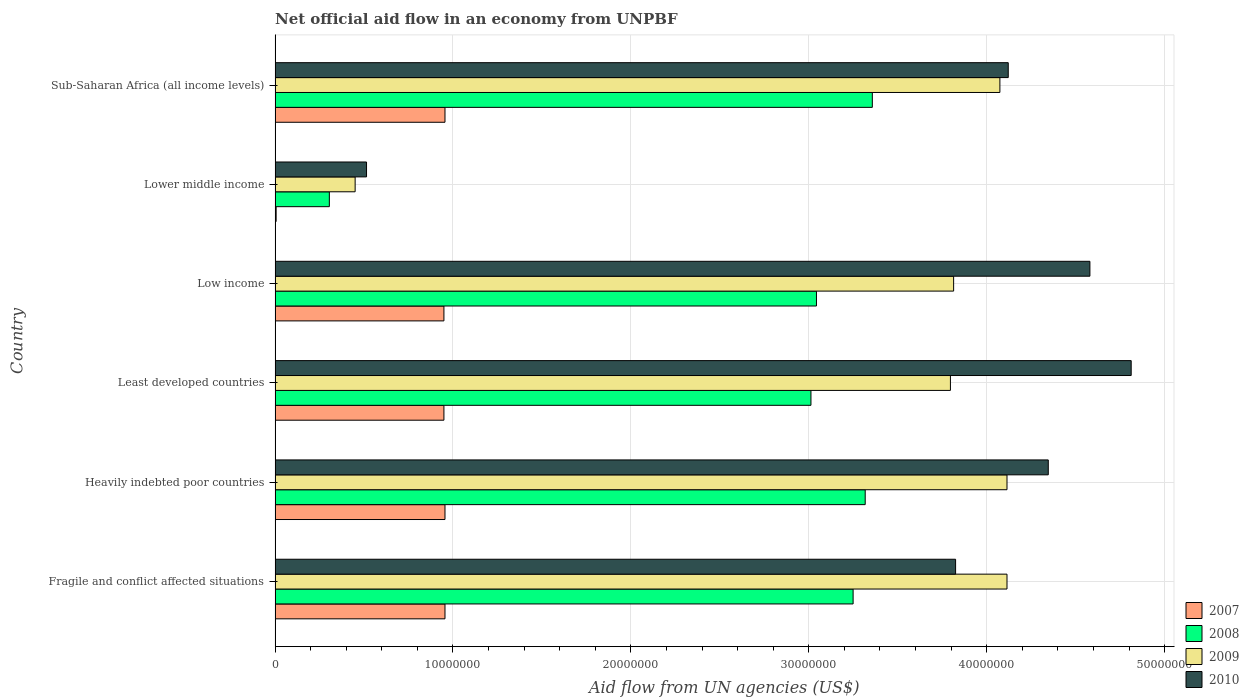How many groups of bars are there?
Give a very brief answer. 6. Are the number of bars per tick equal to the number of legend labels?
Your response must be concise. Yes. Are the number of bars on each tick of the Y-axis equal?
Provide a short and direct response. Yes. What is the label of the 4th group of bars from the top?
Provide a short and direct response. Least developed countries. What is the net official aid flow in 2008 in Fragile and conflict affected situations?
Provide a succinct answer. 3.25e+07. Across all countries, what is the maximum net official aid flow in 2007?
Your response must be concise. 9.55e+06. Across all countries, what is the minimum net official aid flow in 2008?
Give a very brief answer. 3.05e+06. In which country was the net official aid flow in 2007 maximum?
Offer a very short reply. Fragile and conflict affected situations. In which country was the net official aid flow in 2008 minimum?
Offer a terse response. Lower middle income. What is the total net official aid flow in 2007 in the graph?
Provide a succinct answer. 4.77e+07. What is the difference between the net official aid flow in 2010 in Least developed countries and that in Sub-Saharan Africa (all income levels)?
Provide a succinct answer. 6.91e+06. What is the difference between the net official aid flow in 2008 in Heavily indebted poor countries and the net official aid flow in 2009 in Least developed countries?
Provide a short and direct response. -4.79e+06. What is the average net official aid flow in 2007 per country?
Keep it short and to the point. 7.95e+06. What is the difference between the net official aid flow in 2009 and net official aid flow in 2008 in Heavily indebted poor countries?
Your answer should be very brief. 7.97e+06. What is the ratio of the net official aid flow in 2008 in Least developed countries to that in Low income?
Give a very brief answer. 0.99. Is the difference between the net official aid flow in 2009 in Fragile and conflict affected situations and Heavily indebted poor countries greater than the difference between the net official aid flow in 2008 in Fragile and conflict affected situations and Heavily indebted poor countries?
Give a very brief answer. Yes. What is the difference between the highest and the second highest net official aid flow in 2007?
Provide a succinct answer. 0. What is the difference between the highest and the lowest net official aid flow in 2009?
Give a very brief answer. 3.66e+07. In how many countries, is the net official aid flow in 2009 greater than the average net official aid flow in 2009 taken over all countries?
Provide a short and direct response. 5. Is the sum of the net official aid flow in 2010 in Fragile and conflict affected situations and Sub-Saharan Africa (all income levels) greater than the maximum net official aid flow in 2009 across all countries?
Your response must be concise. Yes. What does the 1st bar from the top in Least developed countries represents?
Offer a terse response. 2010. Is it the case that in every country, the sum of the net official aid flow in 2010 and net official aid flow in 2008 is greater than the net official aid flow in 2007?
Keep it short and to the point. Yes. Are all the bars in the graph horizontal?
Provide a succinct answer. Yes. How many countries are there in the graph?
Offer a very short reply. 6. Are the values on the major ticks of X-axis written in scientific E-notation?
Offer a very short reply. No. Where does the legend appear in the graph?
Offer a terse response. Bottom right. What is the title of the graph?
Make the answer very short. Net official aid flow in an economy from UNPBF. Does "1966" appear as one of the legend labels in the graph?
Provide a short and direct response. No. What is the label or title of the X-axis?
Your response must be concise. Aid flow from UN agencies (US$). What is the Aid flow from UN agencies (US$) of 2007 in Fragile and conflict affected situations?
Offer a very short reply. 9.55e+06. What is the Aid flow from UN agencies (US$) in 2008 in Fragile and conflict affected situations?
Offer a very short reply. 3.25e+07. What is the Aid flow from UN agencies (US$) in 2009 in Fragile and conflict affected situations?
Offer a very short reply. 4.11e+07. What is the Aid flow from UN agencies (US$) of 2010 in Fragile and conflict affected situations?
Your answer should be very brief. 3.82e+07. What is the Aid flow from UN agencies (US$) in 2007 in Heavily indebted poor countries?
Offer a terse response. 9.55e+06. What is the Aid flow from UN agencies (US$) of 2008 in Heavily indebted poor countries?
Your response must be concise. 3.32e+07. What is the Aid flow from UN agencies (US$) in 2009 in Heavily indebted poor countries?
Offer a terse response. 4.11e+07. What is the Aid flow from UN agencies (US$) of 2010 in Heavily indebted poor countries?
Offer a terse response. 4.35e+07. What is the Aid flow from UN agencies (US$) of 2007 in Least developed countries?
Offer a terse response. 9.49e+06. What is the Aid flow from UN agencies (US$) in 2008 in Least developed countries?
Offer a very short reply. 3.01e+07. What is the Aid flow from UN agencies (US$) of 2009 in Least developed countries?
Give a very brief answer. 3.80e+07. What is the Aid flow from UN agencies (US$) in 2010 in Least developed countries?
Your answer should be very brief. 4.81e+07. What is the Aid flow from UN agencies (US$) of 2007 in Low income?
Your response must be concise. 9.49e+06. What is the Aid flow from UN agencies (US$) in 2008 in Low income?
Give a very brief answer. 3.04e+07. What is the Aid flow from UN agencies (US$) in 2009 in Low income?
Provide a short and direct response. 3.81e+07. What is the Aid flow from UN agencies (US$) in 2010 in Low income?
Make the answer very short. 4.58e+07. What is the Aid flow from UN agencies (US$) of 2008 in Lower middle income?
Your answer should be very brief. 3.05e+06. What is the Aid flow from UN agencies (US$) of 2009 in Lower middle income?
Your response must be concise. 4.50e+06. What is the Aid flow from UN agencies (US$) in 2010 in Lower middle income?
Your answer should be very brief. 5.14e+06. What is the Aid flow from UN agencies (US$) in 2007 in Sub-Saharan Africa (all income levels)?
Provide a succinct answer. 9.55e+06. What is the Aid flow from UN agencies (US$) in 2008 in Sub-Saharan Africa (all income levels)?
Give a very brief answer. 3.36e+07. What is the Aid flow from UN agencies (US$) of 2009 in Sub-Saharan Africa (all income levels)?
Make the answer very short. 4.07e+07. What is the Aid flow from UN agencies (US$) of 2010 in Sub-Saharan Africa (all income levels)?
Ensure brevity in your answer.  4.12e+07. Across all countries, what is the maximum Aid flow from UN agencies (US$) of 2007?
Make the answer very short. 9.55e+06. Across all countries, what is the maximum Aid flow from UN agencies (US$) in 2008?
Your response must be concise. 3.36e+07. Across all countries, what is the maximum Aid flow from UN agencies (US$) in 2009?
Make the answer very short. 4.11e+07. Across all countries, what is the maximum Aid flow from UN agencies (US$) of 2010?
Your answer should be very brief. 4.81e+07. Across all countries, what is the minimum Aid flow from UN agencies (US$) in 2008?
Your answer should be very brief. 3.05e+06. Across all countries, what is the minimum Aid flow from UN agencies (US$) in 2009?
Provide a succinct answer. 4.50e+06. Across all countries, what is the minimum Aid flow from UN agencies (US$) in 2010?
Provide a succinct answer. 5.14e+06. What is the total Aid flow from UN agencies (US$) in 2007 in the graph?
Make the answer very short. 4.77e+07. What is the total Aid flow from UN agencies (US$) in 2008 in the graph?
Your answer should be very brief. 1.63e+08. What is the total Aid flow from UN agencies (US$) in 2009 in the graph?
Your answer should be compact. 2.04e+08. What is the total Aid flow from UN agencies (US$) in 2010 in the graph?
Provide a short and direct response. 2.22e+08. What is the difference between the Aid flow from UN agencies (US$) of 2007 in Fragile and conflict affected situations and that in Heavily indebted poor countries?
Ensure brevity in your answer.  0. What is the difference between the Aid flow from UN agencies (US$) in 2008 in Fragile and conflict affected situations and that in Heavily indebted poor countries?
Your response must be concise. -6.80e+05. What is the difference between the Aid flow from UN agencies (US$) of 2010 in Fragile and conflict affected situations and that in Heavily indebted poor countries?
Give a very brief answer. -5.21e+06. What is the difference between the Aid flow from UN agencies (US$) of 2007 in Fragile and conflict affected situations and that in Least developed countries?
Provide a succinct answer. 6.00e+04. What is the difference between the Aid flow from UN agencies (US$) of 2008 in Fragile and conflict affected situations and that in Least developed countries?
Your answer should be very brief. 2.37e+06. What is the difference between the Aid flow from UN agencies (US$) of 2009 in Fragile and conflict affected situations and that in Least developed countries?
Provide a short and direct response. 3.18e+06. What is the difference between the Aid flow from UN agencies (US$) of 2010 in Fragile and conflict affected situations and that in Least developed countries?
Ensure brevity in your answer.  -9.87e+06. What is the difference between the Aid flow from UN agencies (US$) in 2007 in Fragile and conflict affected situations and that in Low income?
Make the answer very short. 6.00e+04. What is the difference between the Aid flow from UN agencies (US$) in 2008 in Fragile and conflict affected situations and that in Low income?
Offer a terse response. 2.06e+06. What is the difference between the Aid flow from UN agencies (US$) of 2009 in Fragile and conflict affected situations and that in Low income?
Your answer should be very brief. 3.00e+06. What is the difference between the Aid flow from UN agencies (US$) in 2010 in Fragile and conflict affected situations and that in Low income?
Offer a terse response. -7.55e+06. What is the difference between the Aid flow from UN agencies (US$) of 2007 in Fragile and conflict affected situations and that in Lower middle income?
Offer a terse response. 9.49e+06. What is the difference between the Aid flow from UN agencies (US$) of 2008 in Fragile and conflict affected situations and that in Lower middle income?
Your answer should be very brief. 2.94e+07. What is the difference between the Aid flow from UN agencies (US$) in 2009 in Fragile and conflict affected situations and that in Lower middle income?
Make the answer very short. 3.66e+07. What is the difference between the Aid flow from UN agencies (US$) of 2010 in Fragile and conflict affected situations and that in Lower middle income?
Provide a short and direct response. 3.31e+07. What is the difference between the Aid flow from UN agencies (US$) in 2008 in Fragile and conflict affected situations and that in Sub-Saharan Africa (all income levels)?
Ensure brevity in your answer.  -1.08e+06. What is the difference between the Aid flow from UN agencies (US$) in 2010 in Fragile and conflict affected situations and that in Sub-Saharan Africa (all income levels)?
Your answer should be very brief. -2.96e+06. What is the difference between the Aid flow from UN agencies (US$) of 2007 in Heavily indebted poor countries and that in Least developed countries?
Offer a very short reply. 6.00e+04. What is the difference between the Aid flow from UN agencies (US$) in 2008 in Heavily indebted poor countries and that in Least developed countries?
Your answer should be compact. 3.05e+06. What is the difference between the Aid flow from UN agencies (US$) in 2009 in Heavily indebted poor countries and that in Least developed countries?
Your answer should be very brief. 3.18e+06. What is the difference between the Aid flow from UN agencies (US$) of 2010 in Heavily indebted poor countries and that in Least developed countries?
Make the answer very short. -4.66e+06. What is the difference between the Aid flow from UN agencies (US$) in 2008 in Heavily indebted poor countries and that in Low income?
Offer a terse response. 2.74e+06. What is the difference between the Aid flow from UN agencies (US$) in 2009 in Heavily indebted poor countries and that in Low income?
Ensure brevity in your answer.  3.00e+06. What is the difference between the Aid flow from UN agencies (US$) in 2010 in Heavily indebted poor countries and that in Low income?
Offer a very short reply. -2.34e+06. What is the difference between the Aid flow from UN agencies (US$) of 2007 in Heavily indebted poor countries and that in Lower middle income?
Your answer should be compact. 9.49e+06. What is the difference between the Aid flow from UN agencies (US$) in 2008 in Heavily indebted poor countries and that in Lower middle income?
Make the answer very short. 3.01e+07. What is the difference between the Aid flow from UN agencies (US$) in 2009 in Heavily indebted poor countries and that in Lower middle income?
Give a very brief answer. 3.66e+07. What is the difference between the Aid flow from UN agencies (US$) of 2010 in Heavily indebted poor countries and that in Lower middle income?
Your answer should be compact. 3.83e+07. What is the difference between the Aid flow from UN agencies (US$) in 2008 in Heavily indebted poor countries and that in Sub-Saharan Africa (all income levels)?
Make the answer very short. -4.00e+05. What is the difference between the Aid flow from UN agencies (US$) of 2009 in Heavily indebted poor countries and that in Sub-Saharan Africa (all income levels)?
Your answer should be very brief. 4.00e+05. What is the difference between the Aid flow from UN agencies (US$) in 2010 in Heavily indebted poor countries and that in Sub-Saharan Africa (all income levels)?
Your answer should be compact. 2.25e+06. What is the difference between the Aid flow from UN agencies (US$) of 2007 in Least developed countries and that in Low income?
Make the answer very short. 0. What is the difference between the Aid flow from UN agencies (US$) in 2008 in Least developed countries and that in Low income?
Your response must be concise. -3.10e+05. What is the difference between the Aid flow from UN agencies (US$) in 2009 in Least developed countries and that in Low income?
Provide a succinct answer. -1.80e+05. What is the difference between the Aid flow from UN agencies (US$) of 2010 in Least developed countries and that in Low income?
Your response must be concise. 2.32e+06. What is the difference between the Aid flow from UN agencies (US$) of 2007 in Least developed countries and that in Lower middle income?
Keep it short and to the point. 9.43e+06. What is the difference between the Aid flow from UN agencies (US$) in 2008 in Least developed countries and that in Lower middle income?
Your answer should be compact. 2.71e+07. What is the difference between the Aid flow from UN agencies (US$) in 2009 in Least developed countries and that in Lower middle income?
Give a very brief answer. 3.35e+07. What is the difference between the Aid flow from UN agencies (US$) in 2010 in Least developed countries and that in Lower middle income?
Your response must be concise. 4.30e+07. What is the difference between the Aid flow from UN agencies (US$) of 2008 in Least developed countries and that in Sub-Saharan Africa (all income levels)?
Provide a short and direct response. -3.45e+06. What is the difference between the Aid flow from UN agencies (US$) of 2009 in Least developed countries and that in Sub-Saharan Africa (all income levels)?
Give a very brief answer. -2.78e+06. What is the difference between the Aid flow from UN agencies (US$) in 2010 in Least developed countries and that in Sub-Saharan Africa (all income levels)?
Your answer should be very brief. 6.91e+06. What is the difference between the Aid flow from UN agencies (US$) in 2007 in Low income and that in Lower middle income?
Your response must be concise. 9.43e+06. What is the difference between the Aid flow from UN agencies (US$) of 2008 in Low income and that in Lower middle income?
Offer a terse response. 2.74e+07. What is the difference between the Aid flow from UN agencies (US$) of 2009 in Low income and that in Lower middle income?
Offer a very short reply. 3.36e+07. What is the difference between the Aid flow from UN agencies (US$) of 2010 in Low income and that in Lower middle income?
Provide a short and direct response. 4.07e+07. What is the difference between the Aid flow from UN agencies (US$) of 2007 in Low income and that in Sub-Saharan Africa (all income levels)?
Give a very brief answer. -6.00e+04. What is the difference between the Aid flow from UN agencies (US$) of 2008 in Low income and that in Sub-Saharan Africa (all income levels)?
Keep it short and to the point. -3.14e+06. What is the difference between the Aid flow from UN agencies (US$) of 2009 in Low income and that in Sub-Saharan Africa (all income levels)?
Your response must be concise. -2.60e+06. What is the difference between the Aid flow from UN agencies (US$) of 2010 in Low income and that in Sub-Saharan Africa (all income levels)?
Your answer should be very brief. 4.59e+06. What is the difference between the Aid flow from UN agencies (US$) of 2007 in Lower middle income and that in Sub-Saharan Africa (all income levels)?
Provide a short and direct response. -9.49e+06. What is the difference between the Aid flow from UN agencies (US$) in 2008 in Lower middle income and that in Sub-Saharan Africa (all income levels)?
Offer a very short reply. -3.05e+07. What is the difference between the Aid flow from UN agencies (US$) of 2009 in Lower middle income and that in Sub-Saharan Africa (all income levels)?
Your response must be concise. -3.62e+07. What is the difference between the Aid flow from UN agencies (US$) of 2010 in Lower middle income and that in Sub-Saharan Africa (all income levels)?
Offer a very short reply. -3.61e+07. What is the difference between the Aid flow from UN agencies (US$) in 2007 in Fragile and conflict affected situations and the Aid flow from UN agencies (US$) in 2008 in Heavily indebted poor countries?
Your response must be concise. -2.36e+07. What is the difference between the Aid flow from UN agencies (US$) of 2007 in Fragile and conflict affected situations and the Aid flow from UN agencies (US$) of 2009 in Heavily indebted poor countries?
Give a very brief answer. -3.16e+07. What is the difference between the Aid flow from UN agencies (US$) in 2007 in Fragile and conflict affected situations and the Aid flow from UN agencies (US$) in 2010 in Heavily indebted poor countries?
Ensure brevity in your answer.  -3.39e+07. What is the difference between the Aid flow from UN agencies (US$) of 2008 in Fragile and conflict affected situations and the Aid flow from UN agencies (US$) of 2009 in Heavily indebted poor countries?
Offer a terse response. -8.65e+06. What is the difference between the Aid flow from UN agencies (US$) of 2008 in Fragile and conflict affected situations and the Aid flow from UN agencies (US$) of 2010 in Heavily indebted poor countries?
Your answer should be very brief. -1.10e+07. What is the difference between the Aid flow from UN agencies (US$) in 2009 in Fragile and conflict affected situations and the Aid flow from UN agencies (US$) in 2010 in Heavily indebted poor countries?
Your response must be concise. -2.32e+06. What is the difference between the Aid flow from UN agencies (US$) in 2007 in Fragile and conflict affected situations and the Aid flow from UN agencies (US$) in 2008 in Least developed countries?
Your answer should be very brief. -2.06e+07. What is the difference between the Aid flow from UN agencies (US$) of 2007 in Fragile and conflict affected situations and the Aid flow from UN agencies (US$) of 2009 in Least developed countries?
Keep it short and to the point. -2.84e+07. What is the difference between the Aid flow from UN agencies (US$) in 2007 in Fragile and conflict affected situations and the Aid flow from UN agencies (US$) in 2010 in Least developed countries?
Your answer should be very brief. -3.86e+07. What is the difference between the Aid flow from UN agencies (US$) of 2008 in Fragile and conflict affected situations and the Aid flow from UN agencies (US$) of 2009 in Least developed countries?
Ensure brevity in your answer.  -5.47e+06. What is the difference between the Aid flow from UN agencies (US$) of 2008 in Fragile and conflict affected situations and the Aid flow from UN agencies (US$) of 2010 in Least developed countries?
Offer a terse response. -1.56e+07. What is the difference between the Aid flow from UN agencies (US$) in 2009 in Fragile and conflict affected situations and the Aid flow from UN agencies (US$) in 2010 in Least developed countries?
Provide a succinct answer. -6.98e+06. What is the difference between the Aid flow from UN agencies (US$) in 2007 in Fragile and conflict affected situations and the Aid flow from UN agencies (US$) in 2008 in Low income?
Keep it short and to the point. -2.09e+07. What is the difference between the Aid flow from UN agencies (US$) of 2007 in Fragile and conflict affected situations and the Aid flow from UN agencies (US$) of 2009 in Low income?
Offer a very short reply. -2.86e+07. What is the difference between the Aid flow from UN agencies (US$) in 2007 in Fragile and conflict affected situations and the Aid flow from UN agencies (US$) in 2010 in Low income?
Your answer should be very brief. -3.62e+07. What is the difference between the Aid flow from UN agencies (US$) in 2008 in Fragile and conflict affected situations and the Aid flow from UN agencies (US$) in 2009 in Low income?
Make the answer very short. -5.65e+06. What is the difference between the Aid flow from UN agencies (US$) of 2008 in Fragile and conflict affected situations and the Aid flow from UN agencies (US$) of 2010 in Low income?
Offer a very short reply. -1.33e+07. What is the difference between the Aid flow from UN agencies (US$) in 2009 in Fragile and conflict affected situations and the Aid flow from UN agencies (US$) in 2010 in Low income?
Keep it short and to the point. -4.66e+06. What is the difference between the Aid flow from UN agencies (US$) in 2007 in Fragile and conflict affected situations and the Aid flow from UN agencies (US$) in 2008 in Lower middle income?
Keep it short and to the point. 6.50e+06. What is the difference between the Aid flow from UN agencies (US$) in 2007 in Fragile and conflict affected situations and the Aid flow from UN agencies (US$) in 2009 in Lower middle income?
Ensure brevity in your answer.  5.05e+06. What is the difference between the Aid flow from UN agencies (US$) of 2007 in Fragile and conflict affected situations and the Aid flow from UN agencies (US$) of 2010 in Lower middle income?
Ensure brevity in your answer.  4.41e+06. What is the difference between the Aid flow from UN agencies (US$) in 2008 in Fragile and conflict affected situations and the Aid flow from UN agencies (US$) in 2009 in Lower middle income?
Provide a succinct answer. 2.80e+07. What is the difference between the Aid flow from UN agencies (US$) in 2008 in Fragile and conflict affected situations and the Aid flow from UN agencies (US$) in 2010 in Lower middle income?
Your response must be concise. 2.74e+07. What is the difference between the Aid flow from UN agencies (US$) in 2009 in Fragile and conflict affected situations and the Aid flow from UN agencies (US$) in 2010 in Lower middle income?
Offer a terse response. 3.60e+07. What is the difference between the Aid flow from UN agencies (US$) in 2007 in Fragile and conflict affected situations and the Aid flow from UN agencies (US$) in 2008 in Sub-Saharan Africa (all income levels)?
Provide a succinct answer. -2.40e+07. What is the difference between the Aid flow from UN agencies (US$) of 2007 in Fragile and conflict affected situations and the Aid flow from UN agencies (US$) of 2009 in Sub-Saharan Africa (all income levels)?
Your answer should be compact. -3.12e+07. What is the difference between the Aid flow from UN agencies (US$) of 2007 in Fragile and conflict affected situations and the Aid flow from UN agencies (US$) of 2010 in Sub-Saharan Africa (all income levels)?
Offer a very short reply. -3.17e+07. What is the difference between the Aid flow from UN agencies (US$) of 2008 in Fragile and conflict affected situations and the Aid flow from UN agencies (US$) of 2009 in Sub-Saharan Africa (all income levels)?
Your response must be concise. -8.25e+06. What is the difference between the Aid flow from UN agencies (US$) of 2008 in Fragile and conflict affected situations and the Aid flow from UN agencies (US$) of 2010 in Sub-Saharan Africa (all income levels)?
Provide a succinct answer. -8.72e+06. What is the difference between the Aid flow from UN agencies (US$) of 2009 in Fragile and conflict affected situations and the Aid flow from UN agencies (US$) of 2010 in Sub-Saharan Africa (all income levels)?
Your answer should be very brief. -7.00e+04. What is the difference between the Aid flow from UN agencies (US$) of 2007 in Heavily indebted poor countries and the Aid flow from UN agencies (US$) of 2008 in Least developed countries?
Your response must be concise. -2.06e+07. What is the difference between the Aid flow from UN agencies (US$) in 2007 in Heavily indebted poor countries and the Aid flow from UN agencies (US$) in 2009 in Least developed countries?
Give a very brief answer. -2.84e+07. What is the difference between the Aid flow from UN agencies (US$) in 2007 in Heavily indebted poor countries and the Aid flow from UN agencies (US$) in 2010 in Least developed countries?
Your answer should be very brief. -3.86e+07. What is the difference between the Aid flow from UN agencies (US$) in 2008 in Heavily indebted poor countries and the Aid flow from UN agencies (US$) in 2009 in Least developed countries?
Your response must be concise. -4.79e+06. What is the difference between the Aid flow from UN agencies (US$) of 2008 in Heavily indebted poor countries and the Aid flow from UN agencies (US$) of 2010 in Least developed countries?
Provide a short and direct response. -1.50e+07. What is the difference between the Aid flow from UN agencies (US$) in 2009 in Heavily indebted poor countries and the Aid flow from UN agencies (US$) in 2010 in Least developed countries?
Offer a very short reply. -6.98e+06. What is the difference between the Aid flow from UN agencies (US$) of 2007 in Heavily indebted poor countries and the Aid flow from UN agencies (US$) of 2008 in Low income?
Your response must be concise. -2.09e+07. What is the difference between the Aid flow from UN agencies (US$) of 2007 in Heavily indebted poor countries and the Aid flow from UN agencies (US$) of 2009 in Low income?
Provide a short and direct response. -2.86e+07. What is the difference between the Aid flow from UN agencies (US$) in 2007 in Heavily indebted poor countries and the Aid flow from UN agencies (US$) in 2010 in Low income?
Offer a terse response. -3.62e+07. What is the difference between the Aid flow from UN agencies (US$) of 2008 in Heavily indebted poor countries and the Aid flow from UN agencies (US$) of 2009 in Low income?
Your response must be concise. -4.97e+06. What is the difference between the Aid flow from UN agencies (US$) of 2008 in Heavily indebted poor countries and the Aid flow from UN agencies (US$) of 2010 in Low income?
Provide a succinct answer. -1.26e+07. What is the difference between the Aid flow from UN agencies (US$) in 2009 in Heavily indebted poor countries and the Aid flow from UN agencies (US$) in 2010 in Low income?
Give a very brief answer. -4.66e+06. What is the difference between the Aid flow from UN agencies (US$) in 2007 in Heavily indebted poor countries and the Aid flow from UN agencies (US$) in 2008 in Lower middle income?
Keep it short and to the point. 6.50e+06. What is the difference between the Aid flow from UN agencies (US$) of 2007 in Heavily indebted poor countries and the Aid flow from UN agencies (US$) of 2009 in Lower middle income?
Provide a succinct answer. 5.05e+06. What is the difference between the Aid flow from UN agencies (US$) of 2007 in Heavily indebted poor countries and the Aid flow from UN agencies (US$) of 2010 in Lower middle income?
Offer a very short reply. 4.41e+06. What is the difference between the Aid flow from UN agencies (US$) in 2008 in Heavily indebted poor countries and the Aid flow from UN agencies (US$) in 2009 in Lower middle income?
Ensure brevity in your answer.  2.87e+07. What is the difference between the Aid flow from UN agencies (US$) in 2008 in Heavily indebted poor countries and the Aid flow from UN agencies (US$) in 2010 in Lower middle income?
Make the answer very short. 2.80e+07. What is the difference between the Aid flow from UN agencies (US$) in 2009 in Heavily indebted poor countries and the Aid flow from UN agencies (US$) in 2010 in Lower middle income?
Provide a succinct answer. 3.60e+07. What is the difference between the Aid flow from UN agencies (US$) in 2007 in Heavily indebted poor countries and the Aid flow from UN agencies (US$) in 2008 in Sub-Saharan Africa (all income levels)?
Keep it short and to the point. -2.40e+07. What is the difference between the Aid flow from UN agencies (US$) in 2007 in Heavily indebted poor countries and the Aid flow from UN agencies (US$) in 2009 in Sub-Saharan Africa (all income levels)?
Give a very brief answer. -3.12e+07. What is the difference between the Aid flow from UN agencies (US$) of 2007 in Heavily indebted poor countries and the Aid flow from UN agencies (US$) of 2010 in Sub-Saharan Africa (all income levels)?
Provide a short and direct response. -3.17e+07. What is the difference between the Aid flow from UN agencies (US$) in 2008 in Heavily indebted poor countries and the Aid flow from UN agencies (US$) in 2009 in Sub-Saharan Africa (all income levels)?
Your answer should be compact. -7.57e+06. What is the difference between the Aid flow from UN agencies (US$) in 2008 in Heavily indebted poor countries and the Aid flow from UN agencies (US$) in 2010 in Sub-Saharan Africa (all income levels)?
Offer a terse response. -8.04e+06. What is the difference between the Aid flow from UN agencies (US$) of 2007 in Least developed countries and the Aid flow from UN agencies (US$) of 2008 in Low income?
Ensure brevity in your answer.  -2.09e+07. What is the difference between the Aid flow from UN agencies (US$) in 2007 in Least developed countries and the Aid flow from UN agencies (US$) in 2009 in Low income?
Provide a short and direct response. -2.86e+07. What is the difference between the Aid flow from UN agencies (US$) in 2007 in Least developed countries and the Aid flow from UN agencies (US$) in 2010 in Low income?
Your response must be concise. -3.63e+07. What is the difference between the Aid flow from UN agencies (US$) in 2008 in Least developed countries and the Aid flow from UN agencies (US$) in 2009 in Low income?
Your answer should be compact. -8.02e+06. What is the difference between the Aid flow from UN agencies (US$) in 2008 in Least developed countries and the Aid flow from UN agencies (US$) in 2010 in Low income?
Your response must be concise. -1.57e+07. What is the difference between the Aid flow from UN agencies (US$) of 2009 in Least developed countries and the Aid flow from UN agencies (US$) of 2010 in Low income?
Your answer should be compact. -7.84e+06. What is the difference between the Aid flow from UN agencies (US$) in 2007 in Least developed countries and the Aid flow from UN agencies (US$) in 2008 in Lower middle income?
Offer a very short reply. 6.44e+06. What is the difference between the Aid flow from UN agencies (US$) of 2007 in Least developed countries and the Aid flow from UN agencies (US$) of 2009 in Lower middle income?
Ensure brevity in your answer.  4.99e+06. What is the difference between the Aid flow from UN agencies (US$) in 2007 in Least developed countries and the Aid flow from UN agencies (US$) in 2010 in Lower middle income?
Keep it short and to the point. 4.35e+06. What is the difference between the Aid flow from UN agencies (US$) of 2008 in Least developed countries and the Aid flow from UN agencies (US$) of 2009 in Lower middle income?
Offer a very short reply. 2.56e+07. What is the difference between the Aid flow from UN agencies (US$) of 2008 in Least developed countries and the Aid flow from UN agencies (US$) of 2010 in Lower middle income?
Provide a short and direct response. 2.50e+07. What is the difference between the Aid flow from UN agencies (US$) of 2009 in Least developed countries and the Aid flow from UN agencies (US$) of 2010 in Lower middle income?
Keep it short and to the point. 3.28e+07. What is the difference between the Aid flow from UN agencies (US$) of 2007 in Least developed countries and the Aid flow from UN agencies (US$) of 2008 in Sub-Saharan Africa (all income levels)?
Keep it short and to the point. -2.41e+07. What is the difference between the Aid flow from UN agencies (US$) in 2007 in Least developed countries and the Aid flow from UN agencies (US$) in 2009 in Sub-Saharan Africa (all income levels)?
Offer a terse response. -3.12e+07. What is the difference between the Aid flow from UN agencies (US$) of 2007 in Least developed countries and the Aid flow from UN agencies (US$) of 2010 in Sub-Saharan Africa (all income levels)?
Provide a succinct answer. -3.17e+07. What is the difference between the Aid flow from UN agencies (US$) of 2008 in Least developed countries and the Aid flow from UN agencies (US$) of 2009 in Sub-Saharan Africa (all income levels)?
Ensure brevity in your answer.  -1.06e+07. What is the difference between the Aid flow from UN agencies (US$) of 2008 in Least developed countries and the Aid flow from UN agencies (US$) of 2010 in Sub-Saharan Africa (all income levels)?
Provide a succinct answer. -1.11e+07. What is the difference between the Aid flow from UN agencies (US$) in 2009 in Least developed countries and the Aid flow from UN agencies (US$) in 2010 in Sub-Saharan Africa (all income levels)?
Provide a succinct answer. -3.25e+06. What is the difference between the Aid flow from UN agencies (US$) of 2007 in Low income and the Aid flow from UN agencies (US$) of 2008 in Lower middle income?
Offer a very short reply. 6.44e+06. What is the difference between the Aid flow from UN agencies (US$) of 2007 in Low income and the Aid flow from UN agencies (US$) of 2009 in Lower middle income?
Offer a terse response. 4.99e+06. What is the difference between the Aid flow from UN agencies (US$) of 2007 in Low income and the Aid flow from UN agencies (US$) of 2010 in Lower middle income?
Make the answer very short. 4.35e+06. What is the difference between the Aid flow from UN agencies (US$) of 2008 in Low income and the Aid flow from UN agencies (US$) of 2009 in Lower middle income?
Keep it short and to the point. 2.59e+07. What is the difference between the Aid flow from UN agencies (US$) in 2008 in Low income and the Aid flow from UN agencies (US$) in 2010 in Lower middle income?
Provide a short and direct response. 2.53e+07. What is the difference between the Aid flow from UN agencies (US$) of 2009 in Low income and the Aid flow from UN agencies (US$) of 2010 in Lower middle income?
Ensure brevity in your answer.  3.30e+07. What is the difference between the Aid flow from UN agencies (US$) in 2007 in Low income and the Aid flow from UN agencies (US$) in 2008 in Sub-Saharan Africa (all income levels)?
Offer a terse response. -2.41e+07. What is the difference between the Aid flow from UN agencies (US$) of 2007 in Low income and the Aid flow from UN agencies (US$) of 2009 in Sub-Saharan Africa (all income levels)?
Ensure brevity in your answer.  -3.12e+07. What is the difference between the Aid flow from UN agencies (US$) of 2007 in Low income and the Aid flow from UN agencies (US$) of 2010 in Sub-Saharan Africa (all income levels)?
Offer a very short reply. -3.17e+07. What is the difference between the Aid flow from UN agencies (US$) in 2008 in Low income and the Aid flow from UN agencies (US$) in 2009 in Sub-Saharan Africa (all income levels)?
Make the answer very short. -1.03e+07. What is the difference between the Aid flow from UN agencies (US$) in 2008 in Low income and the Aid flow from UN agencies (US$) in 2010 in Sub-Saharan Africa (all income levels)?
Ensure brevity in your answer.  -1.08e+07. What is the difference between the Aid flow from UN agencies (US$) of 2009 in Low income and the Aid flow from UN agencies (US$) of 2010 in Sub-Saharan Africa (all income levels)?
Offer a terse response. -3.07e+06. What is the difference between the Aid flow from UN agencies (US$) in 2007 in Lower middle income and the Aid flow from UN agencies (US$) in 2008 in Sub-Saharan Africa (all income levels)?
Your response must be concise. -3.35e+07. What is the difference between the Aid flow from UN agencies (US$) of 2007 in Lower middle income and the Aid flow from UN agencies (US$) of 2009 in Sub-Saharan Africa (all income levels)?
Keep it short and to the point. -4.07e+07. What is the difference between the Aid flow from UN agencies (US$) of 2007 in Lower middle income and the Aid flow from UN agencies (US$) of 2010 in Sub-Saharan Africa (all income levels)?
Provide a short and direct response. -4.12e+07. What is the difference between the Aid flow from UN agencies (US$) of 2008 in Lower middle income and the Aid flow from UN agencies (US$) of 2009 in Sub-Saharan Africa (all income levels)?
Offer a terse response. -3.77e+07. What is the difference between the Aid flow from UN agencies (US$) of 2008 in Lower middle income and the Aid flow from UN agencies (US$) of 2010 in Sub-Saharan Africa (all income levels)?
Your response must be concise. -3.82e+07. What is the difference between the Aid flow from UN agencies (US$) of 2009 in Lower middle income and the Aid flow from UN agencies (US$) of 2010 in Sub-Saharan Africa (all income levels)?
Give a very brief answer. -3.67e+07. What is the average Aid flow from UN agencies (US$) of 2007 per country?
Your answer should be compact. 7.95e+06. What is the average Aid flow from UN agencies (US$) of 2008 per country?
Provide a succinct answer. 2.71e+07. What is the average Aid flow from UN agencies (US$) in 2009 per country?
Provide a short and direct response. 3.39e+07. What is the average Aid flow from UN agencies (US$) of 2010 per country?
Offer a terse response. 3.70e+07. What is the difference between the Aid flow from UN agencies (US$) of 2007 and Aid flow from UN agencies (US$) of 2008 in Fragile and conflict affected situations?
Offer a terse response. -2.29e+07. What is the difference between the Aid flow from UN agencies (US$) in 2007 and Aid flow from UN agencies (US$) in 2009 in Fragile and conflict affected situations?
Provide a succinct answer. -3.16e+07. What is the difference between the Aid flow from UN agencies (US$) in 2007 and Aid flow from UN agencies (US$) in 2010 in Fragile and conflict affected situations?
Make the answer very short. -2.87e+07. What is the difference between the Aid flow from UN agencies (US$) in 2008 and Aid flow from UN agencies (US$) in 2009 in Fragile and conflict affected situations?
Offer a terse response. -8.65e+06. What is the difference between the Aid flow from UN agencies (US$) of 2008 and Aid flow from UN agencies (US$) of 2010 in Fragile and conflict affected situations?
Make the answer very short. -5.76e+06. What is the difference between the Aid flow from UN agencies (US$) in 2009 and Aid flow from UN agencies (US$) in 2010 in Fragile and conflict affected situations?
Make the answer very short. 2.89e+06. What is the difference between the Aid flow from UN agencies (US$) in 2007 and Aid flow from UN agencies (US$) in 2008 in Heavily indebted poor countries?
Your answer should be compact. -2.36e+07. What is the difference between the Aid flow from UN agencies (US$) of 2007 and Aid flow from UN agencies (US$) of 2009 in Heavily indebted poor countries?
Your answer should be compact. -3.16e+07. What is the difference between the Aid flow from UN agencies (US$) in 2007 and Aid flow from UN agencies (US$) in 2010 in Heavily indebted poor countries?
Offer a very short reply. -3.39e+07. What is the difference between the Aid flow from UN agencies (US$) in 2008 and Aid flow from UN agencies (US$) in 2009 in Heavily indebted poor countries?
Provide a succinct answer. -7.97e+06. What is the difference between the Aid flow from UN agencies (US$) in 2008 and Aid flow from UN agencies (US$) in 2010 in Heavily indebted poor countries?
Your answer should be compact. -1.03e+07. What is the difference between the Aid flow from UN agencies (US$) of 2009 and Aid flow from UN agencies (US$) of 2010 in Heavily indebted poor countries?
Keep it short and to the point. -2.32e+06. What is the difference between the Aid flow from UN agencies (US$) of 2007 and Aid flow from UN agencies (US$) of 2008 in Least developed countries?
Your answer should be very brief. -2.06e+07. What is the difference between the Aid flow from UN agencies (US$) of 2007 and Aid flow from UN agencies (US$) of 2009 in Least developed countries?
Your answer should be very brief. -2.85e+07. What is the difference between the Aid flow from UN agencies (US$) in 2007 and Aid flow from UN agencies (US$) in 2010 in Least developed countries?
Your answer should be compact. -3.86e+07. What is the difference between the Aid flow from UN agencies (US$) of 2008 and Aid flow from UN agencies (US$) of 2009 in Least developed countries?
Offer a very short reply. -7.84e+06. What is the difference between the Aid flow from UN agencies (US$) in 2008 and Aid flow from UN agencies (US$) in 2010 in Least developed countries?
Make the answer very short. -1.80e+07. What is the difference between the Aid flow from UN agencies (US$) of 2009 and Aid flow from UN agencies (US$) of 2010 in Least developed countries?
Your answer should be compact. -1.02e+07. What is the difference between the Aid flow from UN agencies (US$) of 2007 and Aid flow from UN agencies (US$) of 2008 in Low income?
Offer a terse response. -2.09e+07. What is the difference between the Aid flow from UN agencies (US$) of 2007 and Aid flow from UN agencies (US$) of 2009 in Low income?
Your answer should be very brief. -2.86e+07. What is the difference between the Aid flow from UN agencies (US$) in 2007 and Aid flow from UN agencies (US$) in 2010 in Low income?
Ensure brevity in your answer.  -3.63e+07. What is the difference between the Aid flow from UN agencies (US$) of 2008 and Aid flow from UN agencies (US$) of 2009 in Low income?
Your answer should be compact. -7.71e+06. What is the difference between the Aid flow from UN agencies (US$) in 2008 and Aid flow from UN agencies (US$) in 2010 in Low income?
Ensure brevity in your answer.  -1.54e+07. What is the difference between the Aid flow from UN agencies (US$) of 2009 and Aid flow from UN agencies (US$) of 2010 in Low income?
Keep it short and to the point. -7.66e+06. What is the difference between the Aid flow from UN agencies (US$) in 2007 and Aid flow from UN agencies (US$) in 2008 in Lower middle income?
Provide a succinct answer. -2.99e+06. What is the difference between the Aid flow from UN agencies (US$) of 2007 and Aid flow from UN agencies (US$) of 2009 in Lower middle income?
Your answer should be very brief. -4.44e+06. What is the difference between the Aid flow from UN agencies (US$) in 2007 and Aid flow from UN agencies (US$) in 2010 in Lower middle income?
Make the answer very short. -5.08e+06. What is the difference between the Aid flow from UN agencies (US$) of 2008 and Aid flow from UN agencies (US$) of 2009 in Lower middle income?
Keep it short and to the point. -1.45e+06. What is the difference between the Aid flow from UN agencies (US$) of 2008 and Aid flow from UN agencies (US$) of 2010 in Lower middle income?
Provide a short and direct response. -2.09e+06. What is the difference between the Aid flow from UN agencies (US$) of 2009 and Aid flow from UN agencies (US$) of 2010 in Lower middle income?
Make the answer very short. -6.40e+05. What is the difference between the Aid flow from UN agencies (US$) of 2007 and Aid flow from UN agencies (US$) of 2008 in Sub-Saharan Africa (all income levels)?
Offer a terse response. -2.40e+07. What is the difference between the Aid flow from UN agencies (US$) of 2007 and Aid flow from UN agencies (US$) of 2009 in Sub-Saharan Africa (all income levels)?
Provide a short and direct response. -3.12e+07. What is the difference between the Aid flow from UN agencies (US$) of 2007 and Aid flow from UN agencies (US$) of 2010 in Sub-Saharan Africa (all income levels)?
Give a very brief answer. -3.17e+07. What is the difference between the Aid flow from UN agencies (US$) in 2008 and Aid flow from UN agencies (US$) in 2009 in Sub-Saharan Africa (all income levels)?
Offer a very short reply. -7.17e+06. What is the difference between the Aid flow from UN agencies (US$) in 2008 and Aid flow from UN agencies (US$) in 2010 in Sub-Saharan Africa (all income levels)?
Give a very brief answer. -7.64e+06. What is the difference between the Aid flow from UN agencies (US$) of 2009 and Aid flow from UN agencies (US$) of 2010 in Sub-Saharan Africa (all income levels)?
Provide a short and direct response. -4.70e+05. What is the ratio of the Aid flow from UN agencies (US$) of 2007 in Fragile and conflict affected situations to that in Heavily indebted poor countries?
Offer a terse response. 1. What is the ratio of the Aid flow from UN agencies (US$) in 2008 in Fragile and conflict affected situations to that in Heavily indebted poor countries?
Give a very brief answer. 0.98. What is the ratio of the Aid flow from UN agencies (US$) in 2009 in Fragile and conflict affected situations to that in Heavily indebted poor countries?
Keep it short and to the point. 1. What is the ratio of the Aid flow from UN agencies (US$) of 2010 in Fragile and conflict affected situations to that in Heavily indebted poor countries?
Offer a very short reply. 0.88. What is the ratio of the Aid flow from UN agencies (US$) in 2007 in Fragile and conflict affected situations to that in Least developed countries?
Offer a very short reply. 1.01. What is the ratio of the Aid flow from UN agencies (US$) of 2008 in Fragile and conflict affected situations to that in Least developed countries?
Provide a succinct answer. 1.08. What is the ratio of the Aid flow from UN agencies (US$) of 2009 in Fragile and conflict affected situations to that in Least developed countries?
Give a very brief answer. 1.08. What is the ratio of the Aid flow from UN agencies (US$) of 2010 in Fragile and conflict affected situations to that in Least developed countries?
Your answer should be very brief. 0.79. What is the ratio of the Aid flow from UN agencies (US$) in 2007 in Fragile and conflict affected situations to that in Low income?
Your answer should be very brief. 1.01. What is the ratio of the Aid flow from UN agencies (US$) of 2008 in Fragile and conflict affected situations to that in Low income?
Provide a short and direct response. 1.07. What is the ratio of the Aid flow from UN agencies (US$) of 2009 in Fragile and conflict affected situations to that in Low income?
Offer a terse response. 1.08. What is the ratio of the Aid flow from UN agencies (US$) in 2010 in Fragile and conflict affected situations to that in Low income?
Give a very brief answer. 0.84. What is the ratio of the Aid flow from UN agencies (US$) in 2007 in Fragile and conflict affected situations to that in Lower middle income?
Offer a very short reply. 159.17. What is the ratio of the Aid flow from UN agencies (US$) of 2008 in Fragile and conflict affected situations to that in Lower middle income?
Keep it short and to the point. 10.65. What is the ratio of the Aid flow from UN agencies (US$) in 2009 in Fragile and conflict affected situations to that in Lower middle income?
Your response must be concise. 9.14. What is the ratio of the Aid flow from UN agencies (US$) of 2010 in Fragile and conflict affected situations to that in Lower middle income?
Make the answer very short. 7.44. What is the ratio of the Aid flow from UN agencies (US$) of 2008 in Fragile and conflict affected situations to that in Sub-Saharan Africa (all income levels)?
Provide a short and direct response. 0.97. What is the ratio of the Aid flow from UN agencies (US$) of 2009 in Fragile and conflict affected situations to that in Sub-Saharan Africa (all income levels)?
Provide a short and direct response. 1.01. What is the ratio of the Aid flow from UN agencies (US$) in 2010 in Fragile and conflict affected situations to that in Sub-Saharan Africa (all income levels)?
Provide a short and direct response. 0.93. What is the ratio of the Aid flow from UN agencies (US$) of 2008 in Heavily indebted poor countries to that in Least developed countries?
Your response must be concise. 1.1. What is the ratio of the Aid flow from UN agencies (US$) in 2009 in Heavily indebted poor countries to that in Least developed countries?
Give a very brief answer. 1.08. What is the ratio of the Aid flow from UN agencies (US$) in 2010 in Heavily indebted poor countries to that in Least developed countries?
Provide a short and direct response. 0.9. What is the ratio of the Aid flow from UN agencies (US$) of 2007 in Heavily indebted poor countries to that in Low income?
Provide a succinct answer. 1.01. What is the ratio of the Aid flow from UN agencies (US$) of 2008 in Heavily indebted poor countries to that in Low income?
Your answer should be compact. 1.09. What is the ratio of the Aid flow from UN agencies (US$) of 2009 in Heavily indebted poor countries to that in Low income?
Your response must be concise. 1.08. What is the ratio of the Aid flow from UN agencies (US$) in 2010 in Heavily indebted poor countries to that in Low income?
Give a very brief answer. 0.95. What is the ratio of the Aid flow from UN agencies (US$) of 2007 in Heavily indebted poor countries to that in Lower middle income?
Offer a very short reply. 159.17. What is the ratio of the Aid flow from UN agencies (US$) of 2008 in Heavily indebted poor countries to that in Lower middle income?
Keep it short and to the point. 10.88. What is the ratio of the Aid flow from UN agencies (US$) in 2009 in Heavily indebted poor countries to that in Lower middle income?
Offer a terse response. 9.14. What is the ratio of the Aid flow from UN agencies (US$) of 2010 in Heavily indebted poor countries to that in Lower middle income?
Your response must be concise. 8.46. What is the ratio of the Aid flow from UN agencies (US$) in 2009 in Heavily indebted poor countries to that in Sub-Saharan Africa (all income levels)?
Provide a succinct answer. 1.01. What is the ratio of the Aid flow from UN agencies (US$) of 2010 in Heavily indebted poor countries to that in Sub-Saharan Africa (all income levels)?
Provide a succinct answer. 1.05. What is the ratio of the Aid flow from UN agencies (US$) in 2007 in Least developed countries to that in Low income?
Offer a very short reply. 1. What is the ratio of the Aid flow from UN agencies (US$) in 2010 in Least developed countries to that in Low income?
Provide a short and direct response. 1.05. What is the ratio of the Aid flow from UN agencies (US$) of 2007 in Least developed countries to that in Lower middle income?
Your answer should be compact. 158.17. What is the ratio of the Aid flow from UN agencies (US$) of 2008 in Least developed countries to that in Lower middle income?
Your answer should be compact. 9.88. What is the ratio of the Aid flow from UN agencies (US$) in 2009 in Least developed countries to that in Lower middle income?
Offer a terse response. 8.44. What is the ratio of the Aid flow from UN agencies (US$) in 2010 in Least developed countries to that in Lower middle income?
Provide a short and direct response. 9.36. What is the ratio of the Aid flow from UN agencies (US$) in 2007 in Least developed countries to that in Sub-Saharan Africa (all income levels)?
Provide a short and direct response. 0.99. What is the ratio of the Aid flow from UN agencies (US$) in 2008 in Least developed countries to that in Sub-Saharan Africa (all income levels)?
Make the answer very short. 0.9. What is the ratio of the Aid flow from UN agencies (US$) in 2009 in Least developed countries to that in Sub-Saharan Africa (all income levels)?
Offer a terse response. 0.93. What is the ratio of the Aid flow from UN agencies (US$) of 2010 in Least developed countries to that in Sub-Saharan Africa (all income levels)?
Your answer should be very brief. 1.17. What is the ratio of the Aid flow from UN agencies (US$) in 2007 in Low income to that in Lower middle income?
Your answer should be compact. 158.17. What is the ratio of the Aid flow from UN agencies (US$) of 2008 in Low income to that in Lower middle income?
Offer a terse response. 9.98. What is the ratio of the Aid flow from UN agencies (US$) of 2009 in Low income to that in Lower middle income?
Give a very brief answer. 8.48. What is the ratio of the Aid flow from UN agencies (US$) in 2010 in Low income to that in Lower middle income?
Offer a terse response. 8.91. What is the ratio of the Aid flow from UN agencies (US$) in 2008 in Low income to that in Sub-Saharan Africa (all income levels)?
Give a very brief answer. 0.91. What is the ratio of the Aid flow from UN agencies (US$) of 2009 in Low income to that in Sub-Saharan Africa (all income levels)?
Provide a short and direct response. 0.94. What is the ratio of the Aid flow from UN agencies (US$) of 2010 in Low income to that in Sub-Saharan Africa (all income levels)?
Make the answer very short. 1.11. What is the ratio of the Aid flow from UN agencies (US$) in 2007 in Lower middle income to that in Sub-Saharan Africa (all income levels)?
Offer a very short reply. 0.01. What is the ratio of the Aid flow from UN agencies (US$) of 2008 in Lower middle income to that in Sub-Saharan Africa (all income levels)?
Your response must be concise. 0.09. What is the ratio of the Aid flow from UN agencies (US$) of 2009 in Lower middle income to that in Sub-Saharan Africa (all income levels)?
Give a very brief answer. 0.11. What is the ratio of the Aid flow from UN agencies (US$) of 2010 in Lower middle income to that in Sub-Saharan Africa (all income levels)?
Your answer should be very brief. 0.12. What is the difference between the highest and the second highest Aid flow from UN agencies (US$) in 2007?
Ensure brevity in your answer.  0. What is the difference between the highest and the second highest Aid flow from UN agencies (US$) in 2008?
Your answer should be compact. 4.00e+05. What is the difference between the highest and the second highest Aid flow from UN agencies (US$) in 2010?
Ensure brevity in your answer.  2.32e+06. What is the difference between the highest and the lowest Aid flow from UN agencies (US$) of 2007?
Provide a short and direct response. 9.49e+06. What is the difference between the highest and the lowest Aid flow from UN agencies (US$) of 2008?
Offer a very short reply. 3.05e+07. What is the difference between the highest and the lowest Aid flow from UN agencies (US$) of 2009?
Make the answer very short. 3.66e+07. What is the difference between the highest and the lowest Aid flow from UN agencies (US$) in 2010?
Keep it short and to the point. 4.30e+07. 